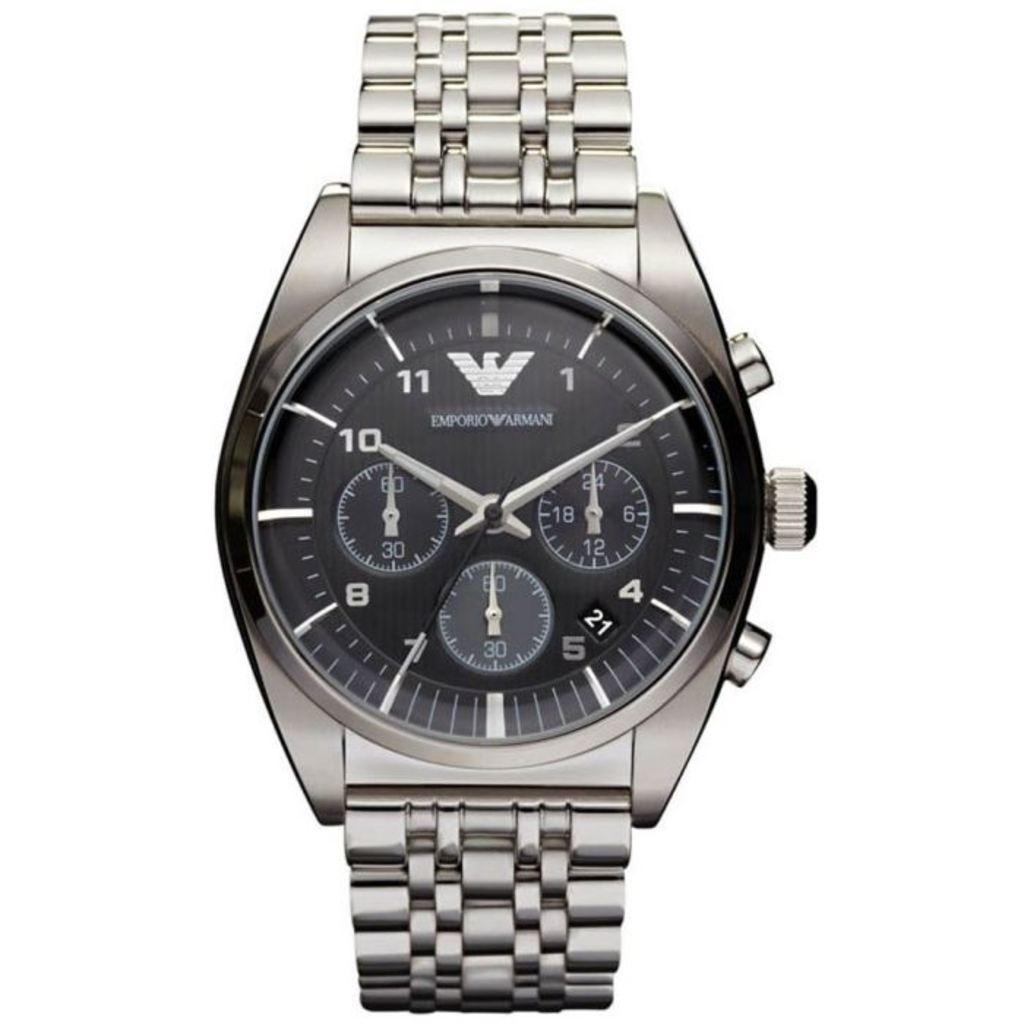<image>
Relay a brief, clear account of the picture shown. The silver and black watch is a Armani branded watch 